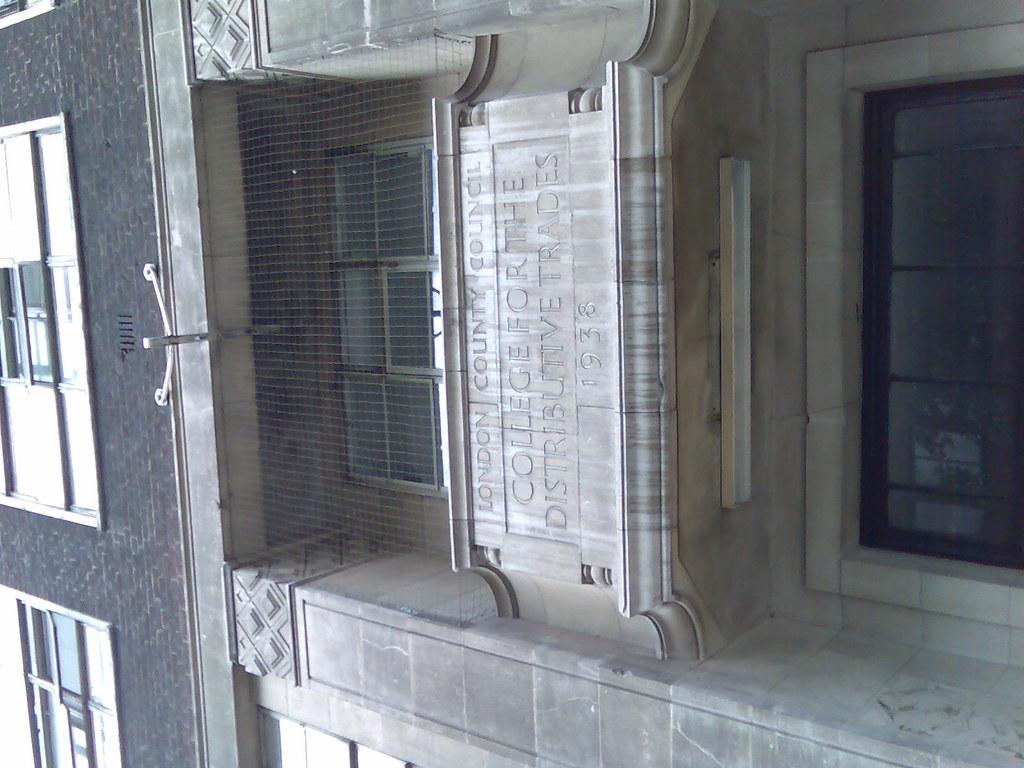What is the main structure in the image? There is a building in the image. What feature can be seen on the building? The building has windows. Is there any text or symbols on the building? Yes, there is writing on the building. What type of actor is performing on the building in the image? There is no actor or performance present in the image; it only features a building with windows and writing. 